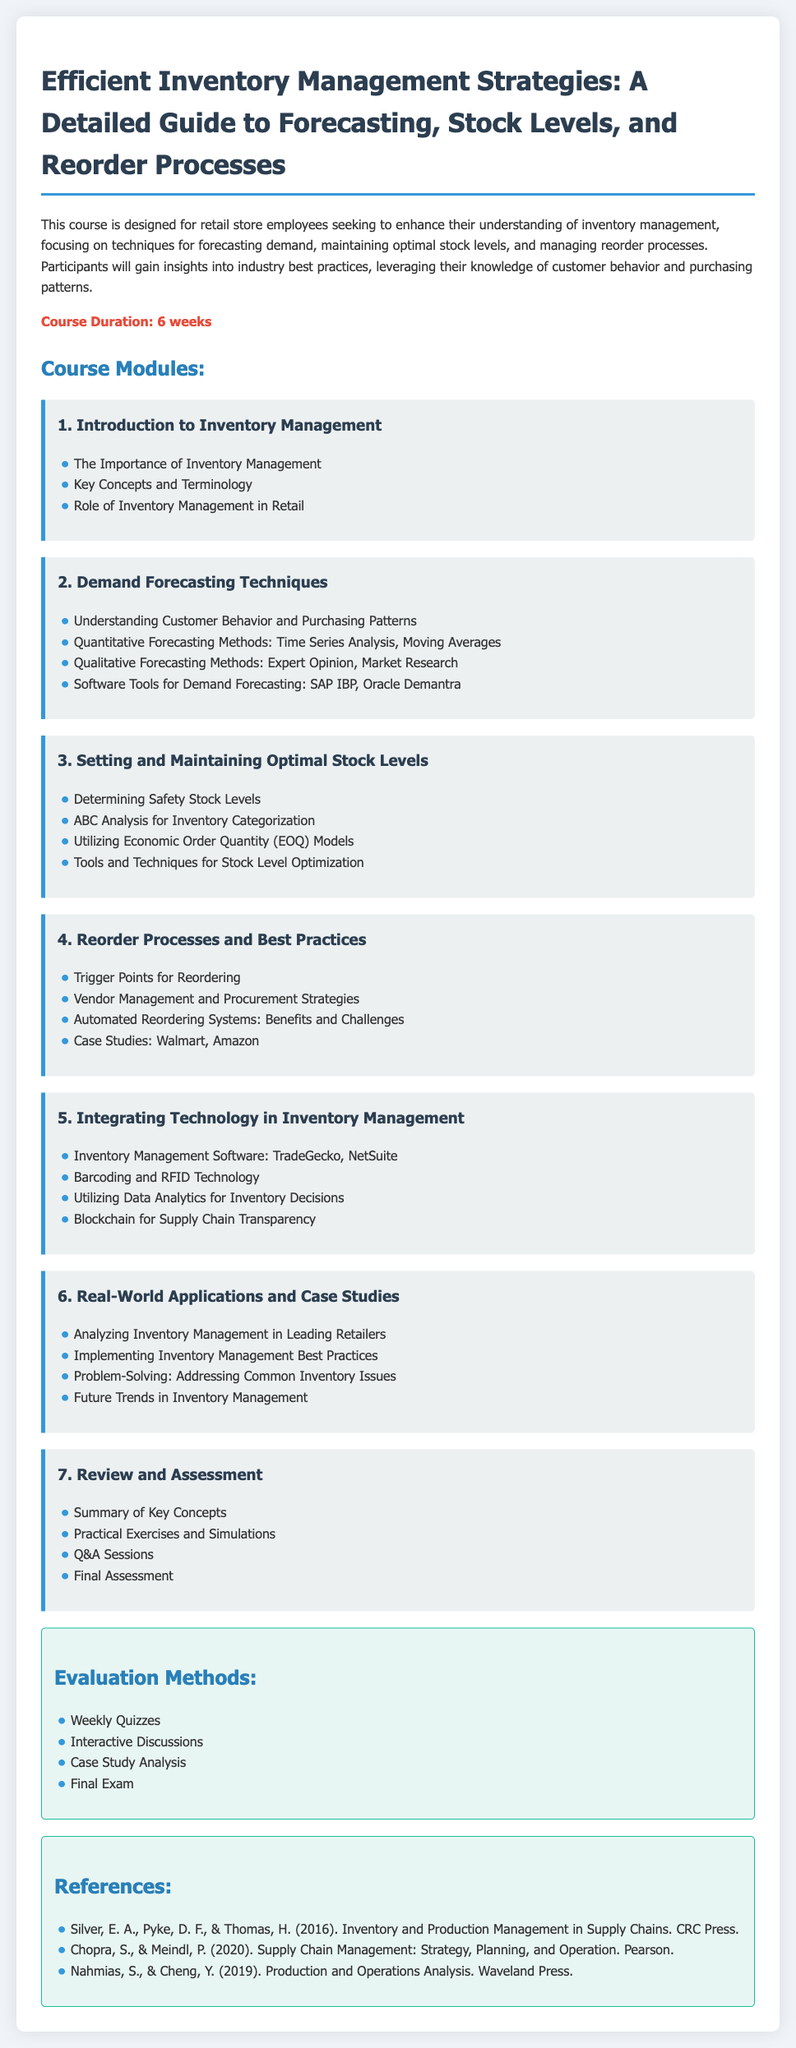What is the course duration? The course duration is stated in the document and is indicated prominently.
Answer: 6 weeks What is the first module about? The first module is titled "Introduction to Inventory Management," which provides foundational knowledge on the subject.
Answer: Introduction to Inventory Management Which software tools are mentioned for demand forecasting? The syllabus lists specific software tools in the Demand Forecasting Techniques module.
Answer: SAP IBP, Oracle Demantra What does EOQ stand for? The abbreviation EOQ is mentioned in the context of setting stock levels, indicating Economic Order Quantity.
Answer: Economic Order Quantity What is the focus of the sixth module? The sixth module revolves around practical applications and understanding real-world scenarios in inventory management.
Answer: Real-World Applications and Case Studies How many evaluation methods are listed? The evaluation section details the number of methods that will be used to assess participant understanding.
Answer: Four Which category does "ABC Analysis" fall under? The ABC Analysis is specifically mentioned in the module on maintaining optimal stock levels.
Answer: Setting and Maintaining Optimal Stock Levels What are automated systems related to in the syllabus? The syllabus outlines automated systems in relation to their benefits and challenges in inventory management processes.
Answer: Reorder Processes and Best Practices What is one of the references cited in the document? References are listed at the end of the syllabus, including books and authors regarding supply chain management.
Answer: Silver, E. A., Pyke, D. F., & Thomas, H. (2016). Inventory and Production Management in Supply Chains. CRC Press 